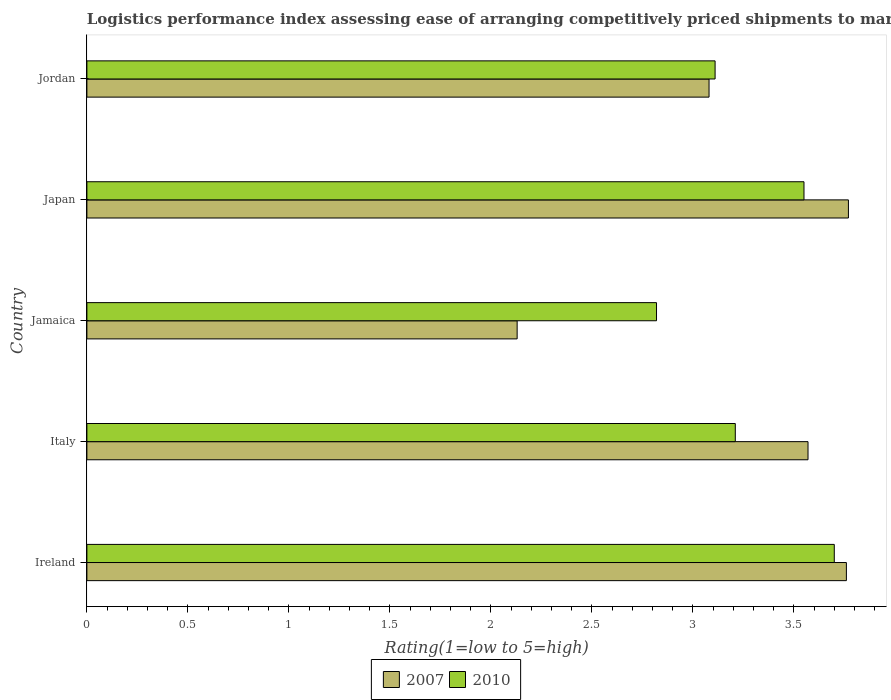How many different coloured bars are there?
Provide a succinct answer. 2. How many groups of bars are there?
Ensure brevity in your answer.  5. Are the number of bars per tick equal to the number of legend labels?
Offer a terse response. Yes. Are the number of bars on each tick of the Y-axis equal?
Provide a short and direct response. Yes. How many bars are there on the 1st tick from the top?
Provide a short and direct response. 2. What is the label of the 2nd group of bars from the top?
Your response must be concise. Japan. What is the Logistic performance index in 2007 in Ireland?
Ensure brevity in your answer.  3.76. Across all countries, what is the maximum Logistic performance index in 2007?
Offer a terse response. 3.77. Across all countries, what is the minimum Logistic performance index in 2010?
Your answer should be compact. 2.82. In which country was the Logistic performance index in 2007 maximum?
Keep it short and to the point. Japan. In which country was the Logistic performance index in 2010 minimum?
Give a very brief answer. Jamaica. What is the total Logistic performance index in 2007 in the graph?
Ensure brevity in your answer.  16.31. What is the difference between the Logistic performance index in 2010 in Jamaica and that in Japan?
Provide a short and direct response. -0.73. What is the difference between the Logistic performance index in 2007 in Italy and the Logistic performance index in 2010 in Japan?
Ensure brevity in your answer.  0.02. What is the average Logistic performance index in 2010 per country?
Provide a short and direct response. 3.28. What is the difference between the Logistic performance index in 2010 and Logistic performance index in 2007 in Jordan?
Provide a succinct answer. 0.03. In how many countries, is the Logistic performance index in 2007 greater than 0.2 ?
Offer a terse response. 5. What is the ratio of the Logistic performance index in 2007 in Jamaica to that in Jordan?
Offer a very short reply. 0.69. Is the difference between the Logistic performance index in 2010 in Italy and Jamaica greater than the difference between the Logistic performance index in 2007 in Italy and Jamaica?
Keep it short and to the point. No. What is the difference between the highest and the second highest Logistic performance index in 2010?
Your response must be concise. 0.15. What is the difference between the highest and the lowest Logistic performance index in 2010?
Provide a short and direct response. 0.88. What does the 2nd bar from the top in Japan represents?
Offer a very short reply. 2007. What does the 1st bar from the bottom in Jordan represents?
Provide a succinct answer. 2007. How many bars are there?
Keep it short and to the point. 10. How many countries are there in the graph?
Provide a succinct answer. 5. Does the graph contain any zero values?
Offer a very short reply. No. Where does the legend appear in the graph?
Provide a short and direct response. Bottom center. How many legend labels are there?
Your answer should be compact. 2. How are the legend labels stacked?
Your answer should be very brief. Horizontal. What is the title of the graph?
Keep it short and to the point. Logistics performance index assessing ease of arranging competitively priced shipments to markets. Does "1997" appear as one of the legend labels in the graph?
Make the answer very short. No. What is the label or title of the X-axis?
Offer a very short reply. Rating(1=low to 5=high). What is the Rating(1=low to 5=high) in 2007 in Ireland?
Provide a short and direct response. 3.76. What is the Rating(1=low to 5=high) in 2007 in Italy?
Ensure brevity in your answer.  3.57. What is the Rating(1=low to 5=high) of 2010 in Italy?
Keep it short and to the point. 3.21. What is the Rating(1=low to 5=high) of 2007 in Jamaica?
Ensure brevity in your answer.  2.13. What is the Rating(1=low to 5=high) in 2010 in Jamaica?
Your answer should be very brief. 2.82. What is the Rating(1=low to 5=high) in 2007 in Japan?
Your answer should be compact. 3.77. What is the Rating(1=low to 5=high) in 2010 in Japan?
Keep it short and to the point. 3.55. What is the Rating(1=low to 5=high) in 2007 in Jordan?
Ensure brevity in your answer.  3.08. What is the Rating(1=low to 5=high) of 2010 in Jordan?
Your response must be concise. 3.11. Across all countries, what is the maximum Rating(1=low to 5=high) of 2007?
Your answer should be compact. 3.77. Across all countries, what is the maximum Rating(1=low to 5=high) in 2010?
Your response must be concise. 3.7. Across all countries, what is the minimum Rating(1=low to 5=high) of 2007?
Offer a terse response. 2.13. Across all countries, what is the minimum Rating(1=low to 5=high) of 2010?
Keep it short and to the point. 2.82. What is the total Rating(1=low to 5=high) of 2007 in the graph?
Keep it short and to the point. 16.31. What is the total Rating(1=low to 5=high) in 2010 in the graph?
Your response must be concise. 16.39. What is the difference between the Rating(1=low to 5=high) of 2007 in Ireland and that in Italy?
Make the answer very short. 0.19. What is the difference between the Rating(1=low to 5=high) of 2010 in Ireland and that in Italy?
Make the answer very short. 0.49. What is the difference between the Rating(1=low to 5=high) of 2007 in Ireland and that in Jamaica?
Ensure brevity in your answer.  1.63. What is the difference between the Rating(1=low to 5=high) of 2007 in Ireland and that in Japan?
Make the answer very short. -0.01. What is the difference between the Rating(1=low to 5=high) of 2010 in Ireland and that in Japan?
Your response must be concise. 0.15. What is the difference between the Rating(1=low to 5=high) of 2007 in Ireland and that in Jordan?
Keep it short and to the point. 0.68. What is the difference between the Rating(1=low to 5=high) of 2010 in Ireland and that in Jordan?
Make the answer very short. 0.59. What is the difference between the Rating(1=low to 5=high) of 2007 in Italy and that in Jamaica?
Offer a very short reply. 1.44. What is the difference between the Rating(1=low to 5=high) in 2010 in Italy and that in Jamaica?
Ensure brevity in your answer.  0.39. What is the difference between the Rating(1=low to 5=high) in 2010 in Italy and that in Japan?
Give a very brief answer. -0.34. What is the difference between the Rating(1=low to 5=high) of 2007 in Italy and that in Jordan?
Offer a very short reply. 0.49. What is the difference between the Rating(1=low to 5=high) of 2010 in Italy and that in Jordan?
Provide a succinct answer. 0.1. What is the difference between the Rating(1=low to 5=high) of 2007 in Jamaica and that in Japan?
Offer a terse response. -1.64. What is the difference between the Rating(1=low to 5=high) in 2010 in Jamaica and that in Japan?
Keep it short and to the point. -0.73. What is the difference between the Rating(1=low to 5=high) of 2007 in Jamaica and that in Jordan?
Your answer should be compact. -0.95. What is the difference between the Rating(1=low to 5=high) of 2010 in Jamaica and that in Jordan?
Ensure brevity in your answer.  -0.29. What is the difference between the Rating(1=low to 5=high) of 2007 in Japan and that in Jordan?
Your response must be concise. 0.69. What is the difference between the Rating(1=low to 5=high) of 2010 in Japan and that in Jordan?
Offer a very short reply. 0.44. What is the difference between the Rating(1=low to 5=high) of 2007 in Ireland and the Rating(1=low to 5=high) of 2010 in Italy?
Give a very brief answer. 0.55. What is the difference between the Rating(1=low to 5=high) of 2007 in Ireland and the Rating(1=low to 5=high) of 2010 in Japan?
Your answer should be very brief. 0.21. What is the difference between the Rating(1=low to 5=high) of 2007 in Ireland and the Rating(1=low to 5=high) of 2010 in Jordan?
Provide a succinct answer. 0.65. What is the difference between the Rating(1=low to 5=high) of 2007 in Italy and the Rating(1=low to 5=high) of 2010 in Jamaica?
Keep it short and to the point. 0.75. What is the difference between the Rating(1=low to 5=high) in 2007 in Italy and the Rating(1=low to 5=high) in 2010 in Japan?
Provide a short and direct response. 0.02. What is the difference between the Rating(1=low to 5=high) of 2007 in Italy and the Rating(1=low to 5=high) of 2010 in Jordan?
Your answer should be very brief. 0.46. What is the difference between the Rating(1=low to 5=high) of 2007 in Jamaica and the Rating(1=low to 5=high) of 2010 in Japan?
Provide a short and direct response. -1.42. What is the difference between the Rating(1=low to 5=high) of 2007 in Jamaica and the Rating(1=low to 5=high) of 2010 in Jordan?
Offer a very short reply. -0.98. What is the difference between the Rating(1=low to 5=high) in 2007 in Japan and the Rating(1=low to 5=high) in 2010 in Jordan?
Provide a short and direct response. 0.66. What is the average Rating(1=low to 5=high) in 2007 per country?
Your response must be concise. 3.26. What is the average Rating(1=low to 5=high) in 2010 per country?
Make the answer very short. 3.28. What is the difference between the Rating(1=low to 5=high) in 2007 and Rating(1=low to 5=high) in 2010 in Italy?
Your response must be concise. 0.36. What is the difference between the Rating(1=low to 5=high) of 2007 and Rating(1=low to 5=high) of 2010 in Jamaica?
Keep it short and to the point. -0.69. What is the difference between the Rating(1=low to 5=high) in 2007 and Rating(1=low to 5=high) in 2010 in Japan?
Offer a terse response. 0.22. What is the difference between the Rating(1=low to 5=high) of 2007 and Rating(1=low to 5=high) of 2010 in Jordan?
Give a very brief answer. -0.03. What is the ratio of the Rating(1=low to 5=high) in 2007 in Ireland to that in Italy?
Keep it short and to the point. 1.05. What is the ratio of the Rating(1=low to 5=high) of 2010 in Ireland to that in Italy?
Provide a short and direct response. 1.15. What is the ratio of the Rating(1=low to 5=high) in 2007 in Ireland to that in Jamaica?
Give a very brief answer. 1.77. What is the ratio of the Rating(1=low to 5=high) in 2010 in Ireland to that in Jamaica?
Give a very brief answer. 1.31. What is the ratio of the Rating(1=low to 5=high) in 2010 in Ireland to that in Japan?
Provide a succinct answer. 1.04. What is the ratio of the Rating(1=low to 5=high) of 2007 in Ireland to that in Jordan?
Offer a terse response. 1.22. What is the ratio of the Rating(1=low to 5=high) of 2010 in Ireland to that in Jordan?
Offer a terse response. 1.19. What is the ratio of the Rating(1=low to 5=high) of 2007 in Italy to that in Jamaica?
Give a very brief answer. 1.68. What is the ratio of the Rating(1=low to 5=high) in 2010 in Italy to that in Jamaica?
Provide a succinct answer. 1.14. What is the ratio of the Rating(1=low to 5=high) of 2007 in Italy to that in Japan?
Your answer should be compact. 0.95. What is the ratio of the Rating(1=low to 5=high) in 2010 in Italy to that in Japan?
Ensure brevity in your answer.  0.9. What is the ratio of the Rating(1=low to 5=high) in 2007 in Italy to that in Jordan?
Give a very brief answer. 1.16. What is the ratio of the Rating(1=low to 5=high) of 2010 in Italy to that in Jordan?
Offer a very short reply. 1.03. What is the ratio of the Rating(1=low to 5=high) in 2007 in Jamaica to that in Japan?
Your answer should be compact. 0.56. What is the ratio of the Rating(1=low to 5=high) of 2010 in Jamaica to that in Japan?
Provide a short and direct response. 0.79. What is the ratio of the Rating(1=low to 5=high) of 2007 in Jamaica to that in Jordan?
Provide a succinct answer. 0.69. What is the ratio of the Rating(1=low to 5=high) in 2010 in Jamaica to that in Jordan?
Ensure brevity in your answer.  0.91. What is the ratio of the Rating(1=low to 5=high) of 2007 in Japan to that in Jordan?
Provide a short and direct response. 1.22. What is the ratio of the Rating(1=low to 5=high) in 2010 in Japan to that in Jordan?
Give a very brief answer. 1.14. What is the difference between the highest and the lowest Rating(1=low to 5=high) in 2007?
Ensure brevity in your answer.  1.64. 